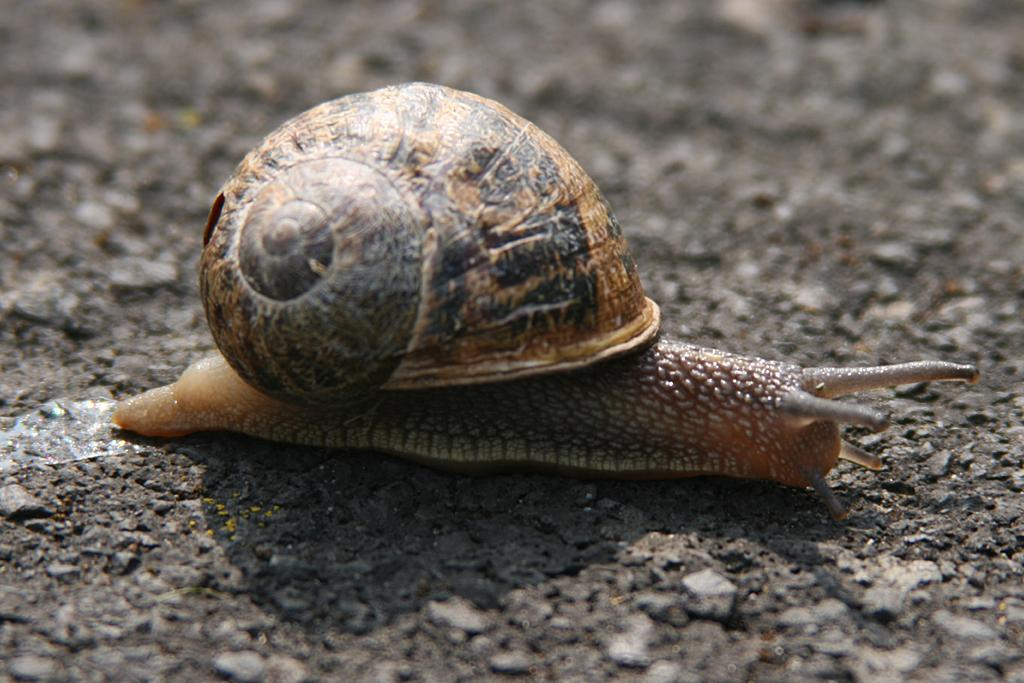What type of animal is in the image? There is a snail in the image. Where is the snail located? The snail is on the ground. Can you describe the background of the image? The background of the image is blurred. What type of engine can be seen powering the snail in the image? There is no engine present in the image, as it features a snail on the ground. What type of nut is the snail holding in its mouth in the image? There is no nut visible in the image, as it only features a snail on the ground. 